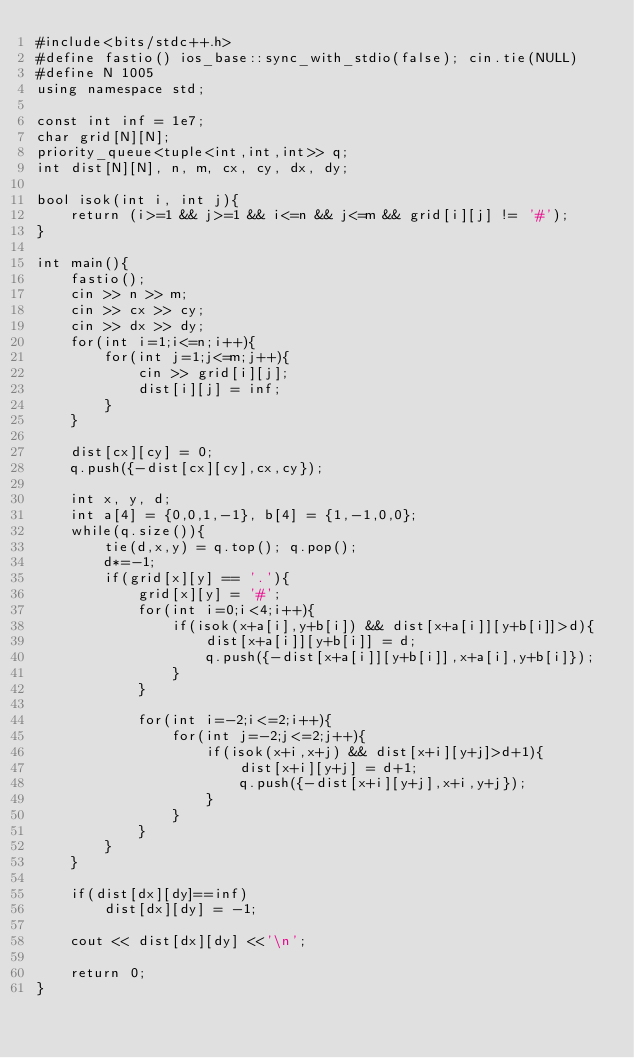Convert code to text. <code><loc_0><loc_0><loc_500><loc_500><_C++_>#include<bits/stdc++.h>
#define fastio() ios_base::sync_with_stdio(false); cin.tie(NULL)
#define N 1005
using namespace std;

const int inf = 1e7;
char grid[N][N];
priority_queue<tuple<int,int,int>> q;
int dist[N][N], n, m, cx, cy, dx, dy;

bool isok(int i, int j){
    return (i>=1 && j>=1 && i<=n && j<=m && grid[i][j] != '#');
}

int main(){
    fastio();
    cin >> n >> m;
    cin >> cx >> cy;
    cin >> dx >> dy;
    for(int i=1;i<=n;i++){
        for(int j=1;j<=m;j++){
            cin >> grid[i][j];
            dist[i][j] = inf;
        }
    }

    dist[cx][cy] = 0;
    q.push({-dist[cx][cy],cx,cy});

    int x, y, d;
    int a[4] = {0,0,1,-1}, b[4] = {1,-1,0,0};
    while(q.size()){
        tie(d,x,y) = q.top(); q.pop();
        d*=-1; 
        if(grid[x][y] == '.'){
            grid[x][y] = '#';
            for(int i=0;i<4;i++){
                if(isok(x+a[i],y+b[i]) && dist[x+a[i]][y+b[i]]>d){
                    dist[x+a[i]][y+b[i]] = d;
                    q.push({-dist[x+a[i]][y+b[i]],x+a[i],y+b[i]}); 
                }
            }

            for(int i=-2;i<=2;i++){
                for(int j=-2;j<=2;j++){
                    if(isok(x+i,x+j) && dist[x+i][y+j]>d+1){
                        dist[x+i][y+j] = d+1;
                        q.push({-dist[x+i][y+j],x+i,y+j});
                    }
                }
            }
        }
    }
    
    if(dist[dx][dy]==inf)
        dist[dx][dy] = -1;

    cout << dist[dx][dy] <<'\n';

    return 0;
}</code> 